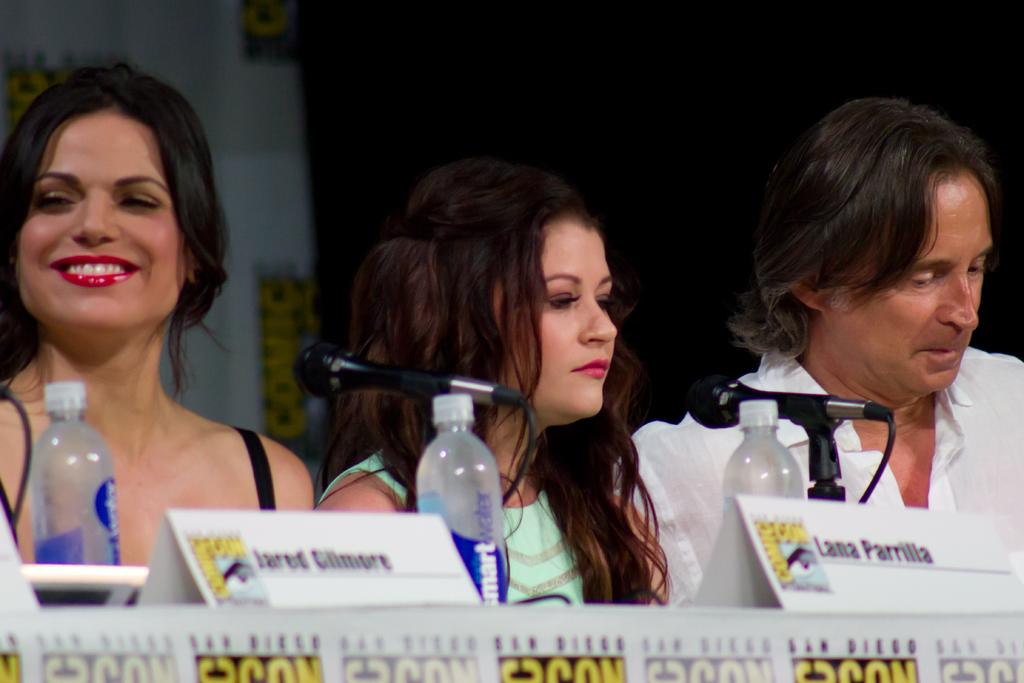How many people are in the image? There are three persons in the image. What objects are on the table in the image? There are microphones, bottles, and name boards on the table. What is the color of the background in the image? The background of the image is dark. What time is displayed on the hourglass in the image? There is no hourglass present in the image. What type of pants are the persons wearing in the image? The provided facts do not mention the type of pants the persons are wearing. 